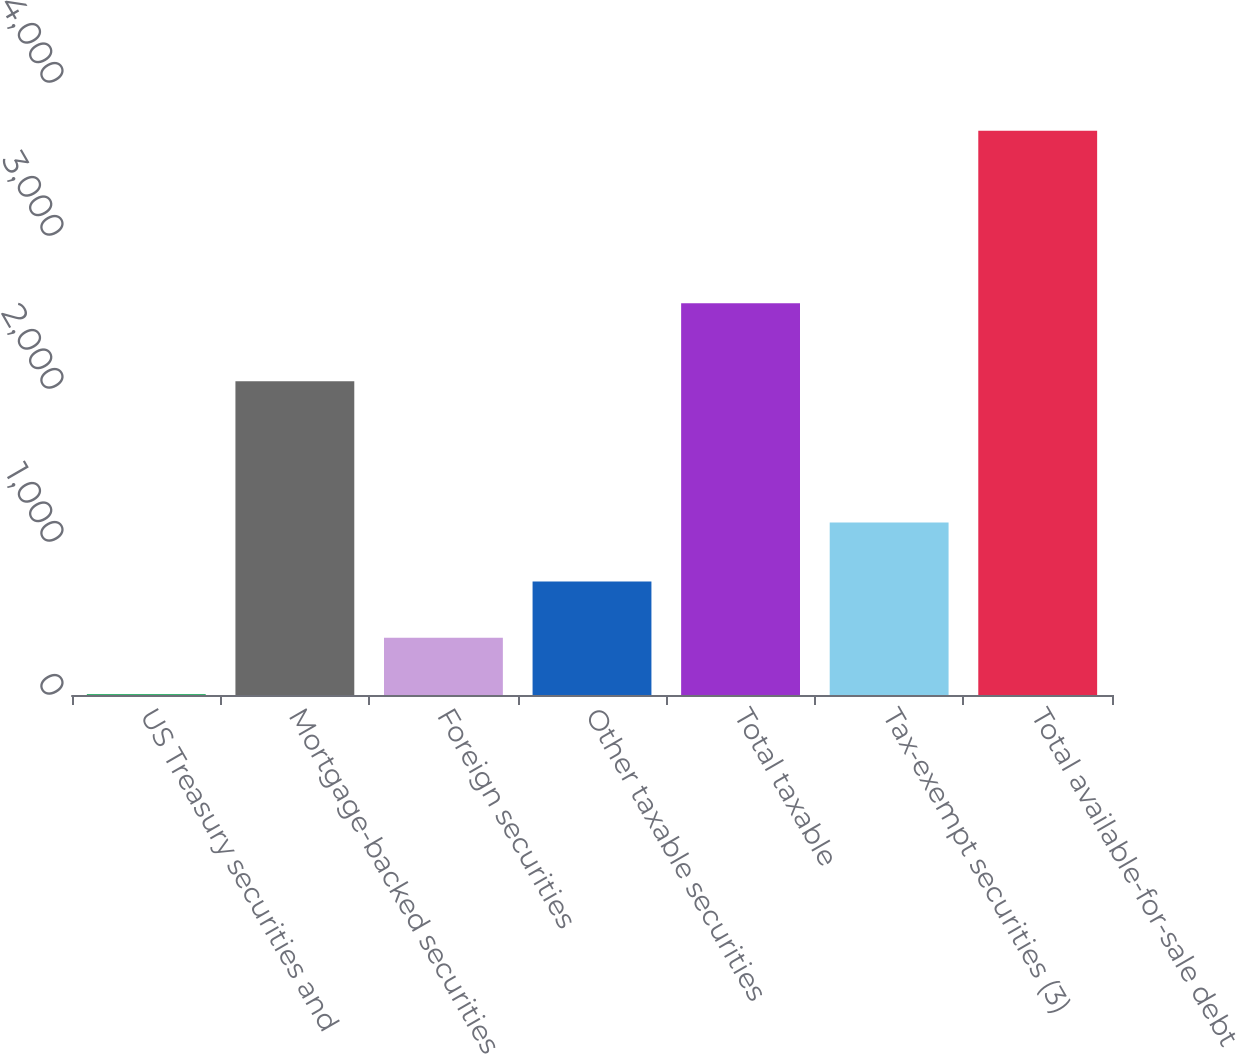Convert chart to OTSL. <chart><loc_0><loc_0><loc_500><loc_500><bar_chart><fcel>US Treasury securities and<fcel>Mortgage-backed securities<fcel>Foreign securities<fcel>Other taxable securities<fcel>Total taxable<fcel>Tax-exempt securities (3)<fcel>Total available-for-sale debt<nl><fcel>6<fcel>2050<fcel>374.2<fcel>742.4<fcel>2560<fcel>1128<fcel>3688<nl></chart> 